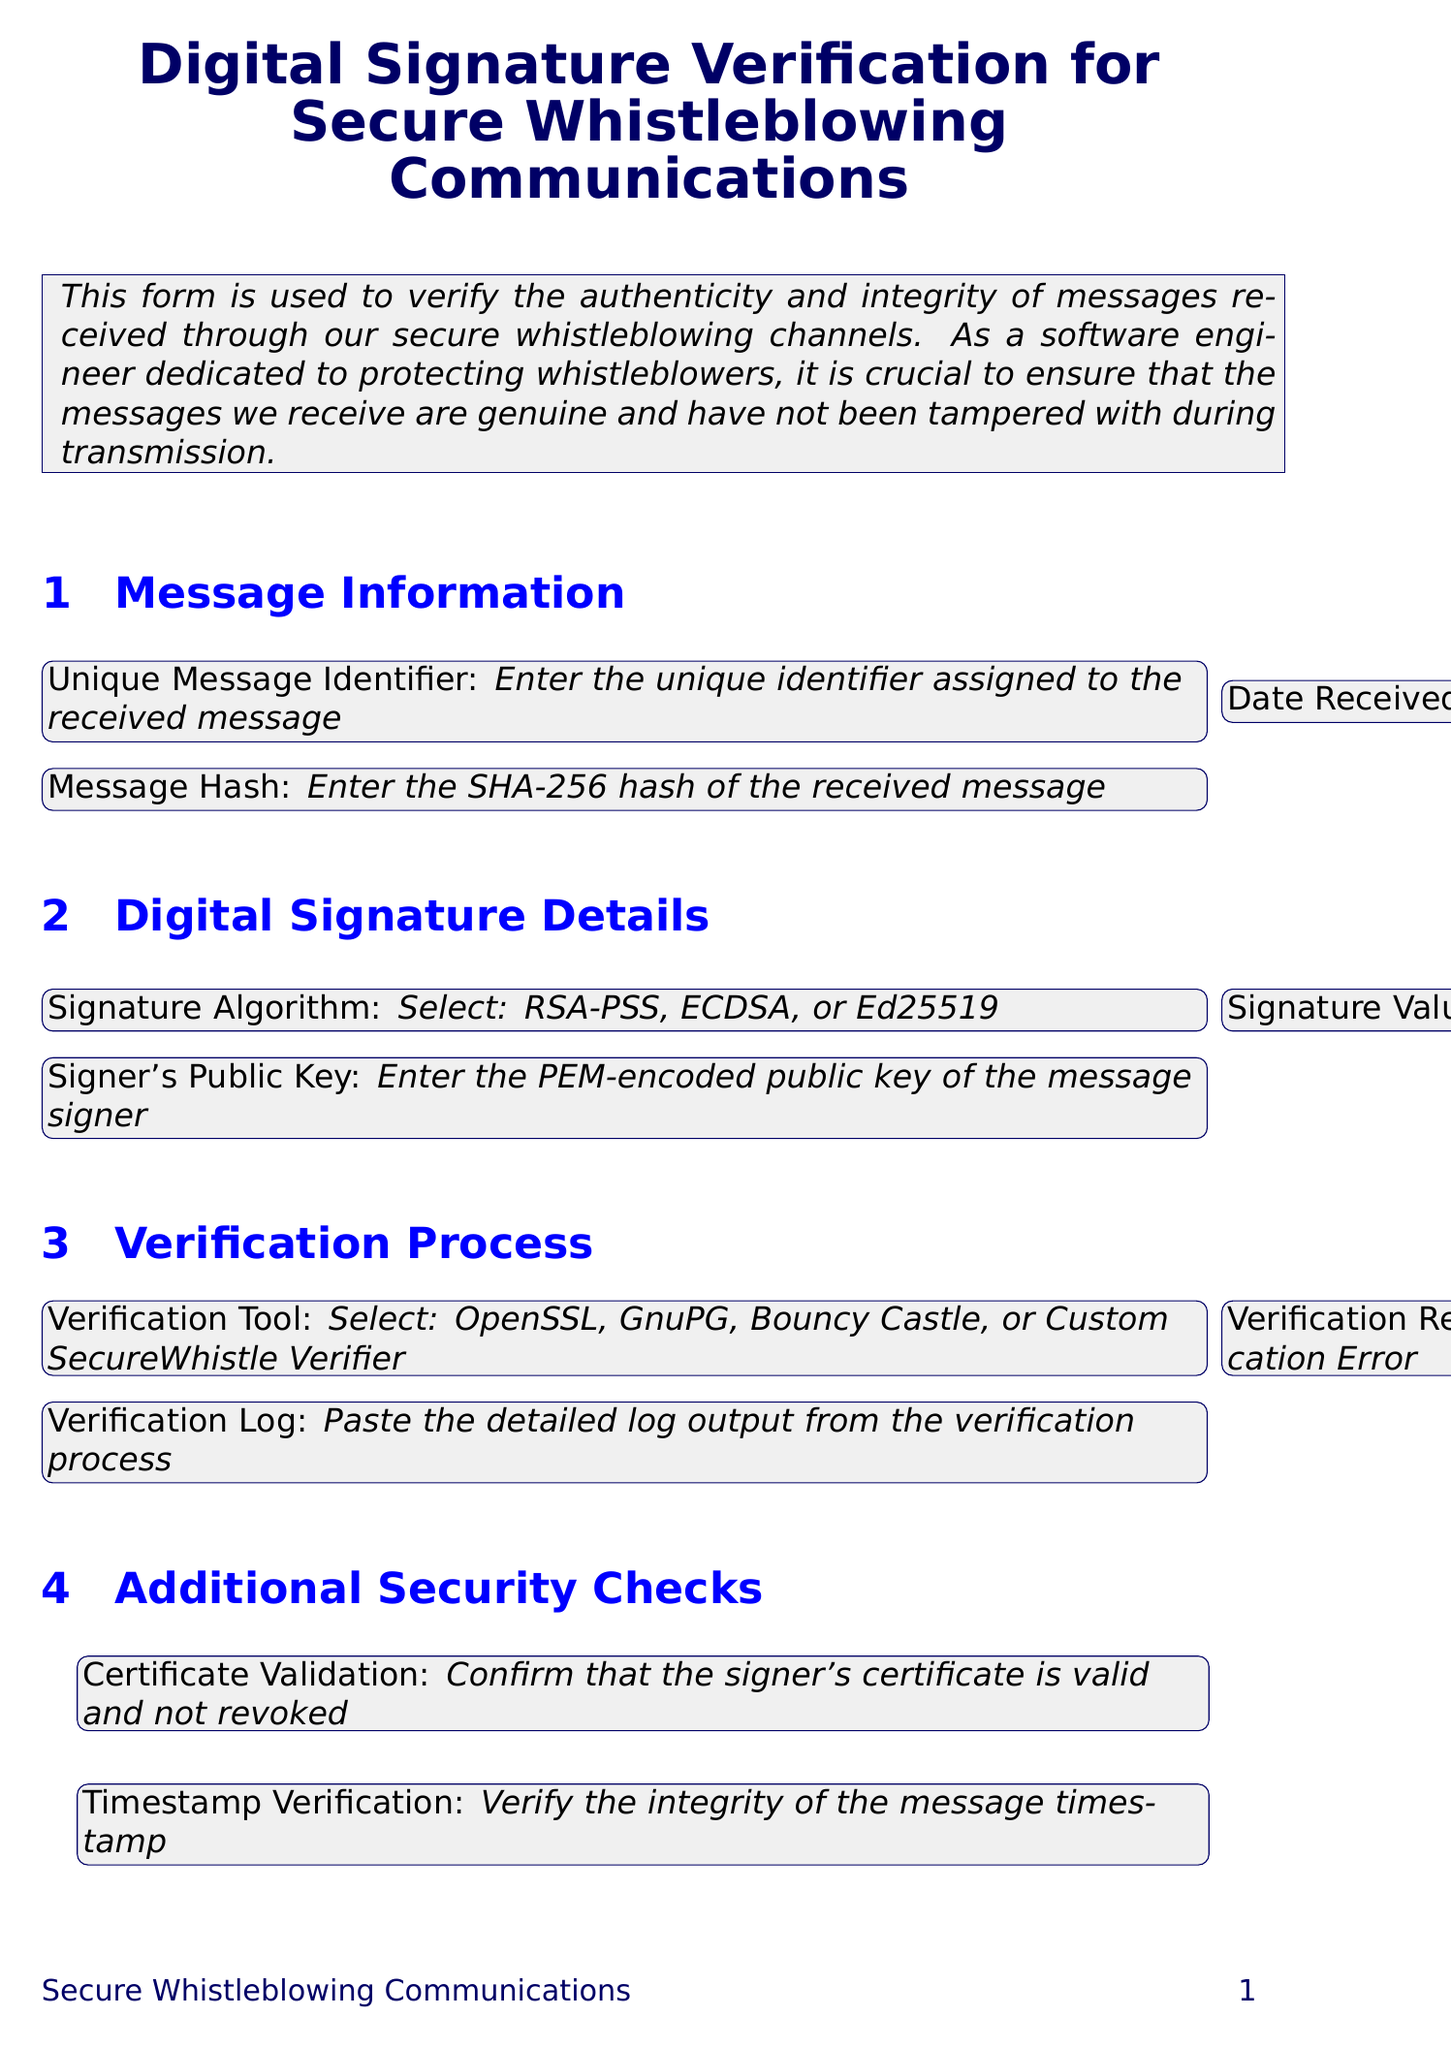What is the form title? The title is given at the top of the document, specifying the purpose of the form.
Answer: Digital Signature Verification for Secure Whistleblowing Communications What is the date format for the 'Date Received' field? The document states that the user needs to select a date, indicating a date format.
Answer: Date What should be pasted in the 'Signature Value' field? The description specifies what kind of data is expected to be inputted in this field.
Answer: Base64-encoded digital signature Which algorithm options are available for digital signature? The options provided in the dropdown menu indicate which algorithms can be selected.
Answer: RSA-PSS, ECDSA, Ed25519 What is confirmed in the 'Certificate Validation' checkbox? This field contains a question that pertains to the validation status of the signer's certificate.
Answer: Signer's certificate is valid and not revoked Which verification tool options are mentioned? The document lists tools available for checking the signature validity.
Answer: OpenSSL, GnuPG, Bouncy Castle, Custom SecureWhistle Verifier What should be entered in the 'Reviewer Name' field? The document describes what information should be provided in this specific section.
Answer: Name of the person verifying the digital signature What should be included in the 'Verification Log' field? The field describes what type of output should be documented during the verification process.
Answer: Detailed log output from the verification process What is the submission action URL for the verification report? This URL is specified in the document for where to send the completed verification.
Answer: https://api.securewhistle.org/submit-verification 